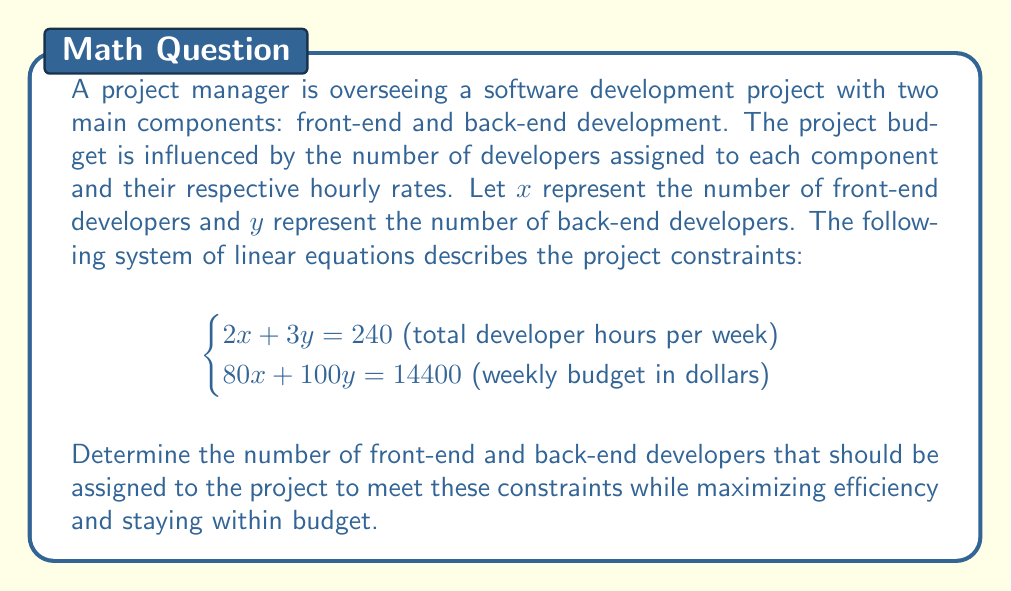Can you answer this question? To solve this system of linear equations, we'll use the substitution method:

1) From the first equation, express $y$ in terms of $x$:
   $$2x + 3y = 240$$
   $$3y = 240 - 2x$$
   $$y = 80 - \frac{2}{3}x$$

2) Substitute this expression for $y$ into the second equation:
   $$80x + 100(80 - \frac{2}{3}x) = 14400$$

3) Simplify:
   $$80x + 8000 - \frac{200}{3}x = 14400$$
   $$80x - \frac{200}{3}x = 6400$$
   $$\frac{240x - 200x}{3} = 6400$$
   $$\frac{40x}{3} = 6400$$

4) Solve for $x$:
   $$40x = 19200$$
   $$x = 480$$

5) Substitute $x = 480$ back into the equation for $y$:
   $$y = 80 - \frac{2}{3}(480) = 80 - 320 = -240$$

6) However, we can't have a negative number of developers. This means our initial assumption that both $x$ and $y$ are positive is incorrect. We need to consider the constraints of our problem.

7) Given that we can't have negative developers, let's solve the system by setting $y = 0$ (minimum possible value) in both equations:

   From $2x + 3y = 240$:
   $$2x = 240$$
   $$x = 120$$

   Check if this satisfies the budget constraint:
   $$80(120) + 100(0) = 9600 < 14400$$

8) Now, let's set $x = 0$ and solve for $y$:

   From $2x + 3y = 240$:
   $$3y = 240$$
   $$y = 80$$

   Check the budget constraint:
   $$80(0) + 100(80) = 8000 < 14400$$

9) The optimal solution will be between these two points. We can use the budget constraint to find it:

   $$80x + 100y = 14400$$
   $$y = 144 - 0.8x$$

   Substitute this into $2x + 3y = 240$:
   $$2x + 3(144 - 0.8x) = 240$$
   $$2x + 432 - 2.4x = 240$$
   $$-0.4x = -192$$
   $$x = 480$$

   Then:
   $$y = 144 - 0.8(480) = 144 - 384 = -240$$

10) Again, we can't have negative developers. The closest integer solution that satisfies both constraints is:
    $$x = 90 \text{ and } y = 20$$

    This gives:
    $$2(90) + 3(20) = 240 \text{ hours}$$
    $$80(90) + 100(20) = 9200 < 14400 \text{ dollars}$$
Answer: 90 front-end developers, 20 back-end developers 